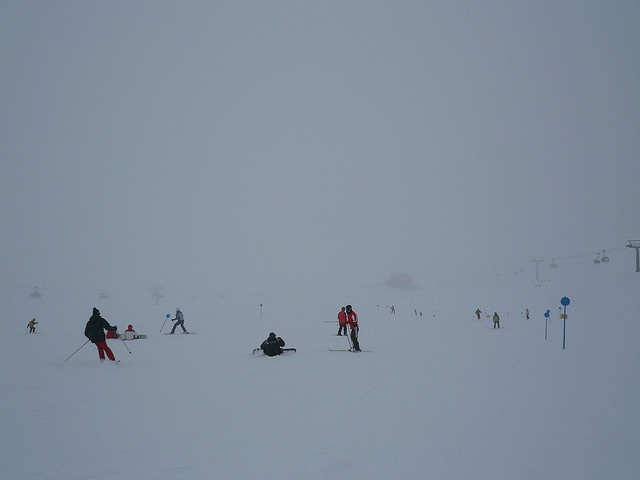Describe the objects in this image and their specific colors. I can see people in gray, black, maroon, and darkgray tones, people in gray, black, purple, and darkgray tones, people in gray, black, and maroon tones, people in gray, darkgray, and black tones, and people in gray, maroon, black, and darkgray tones in this image. 